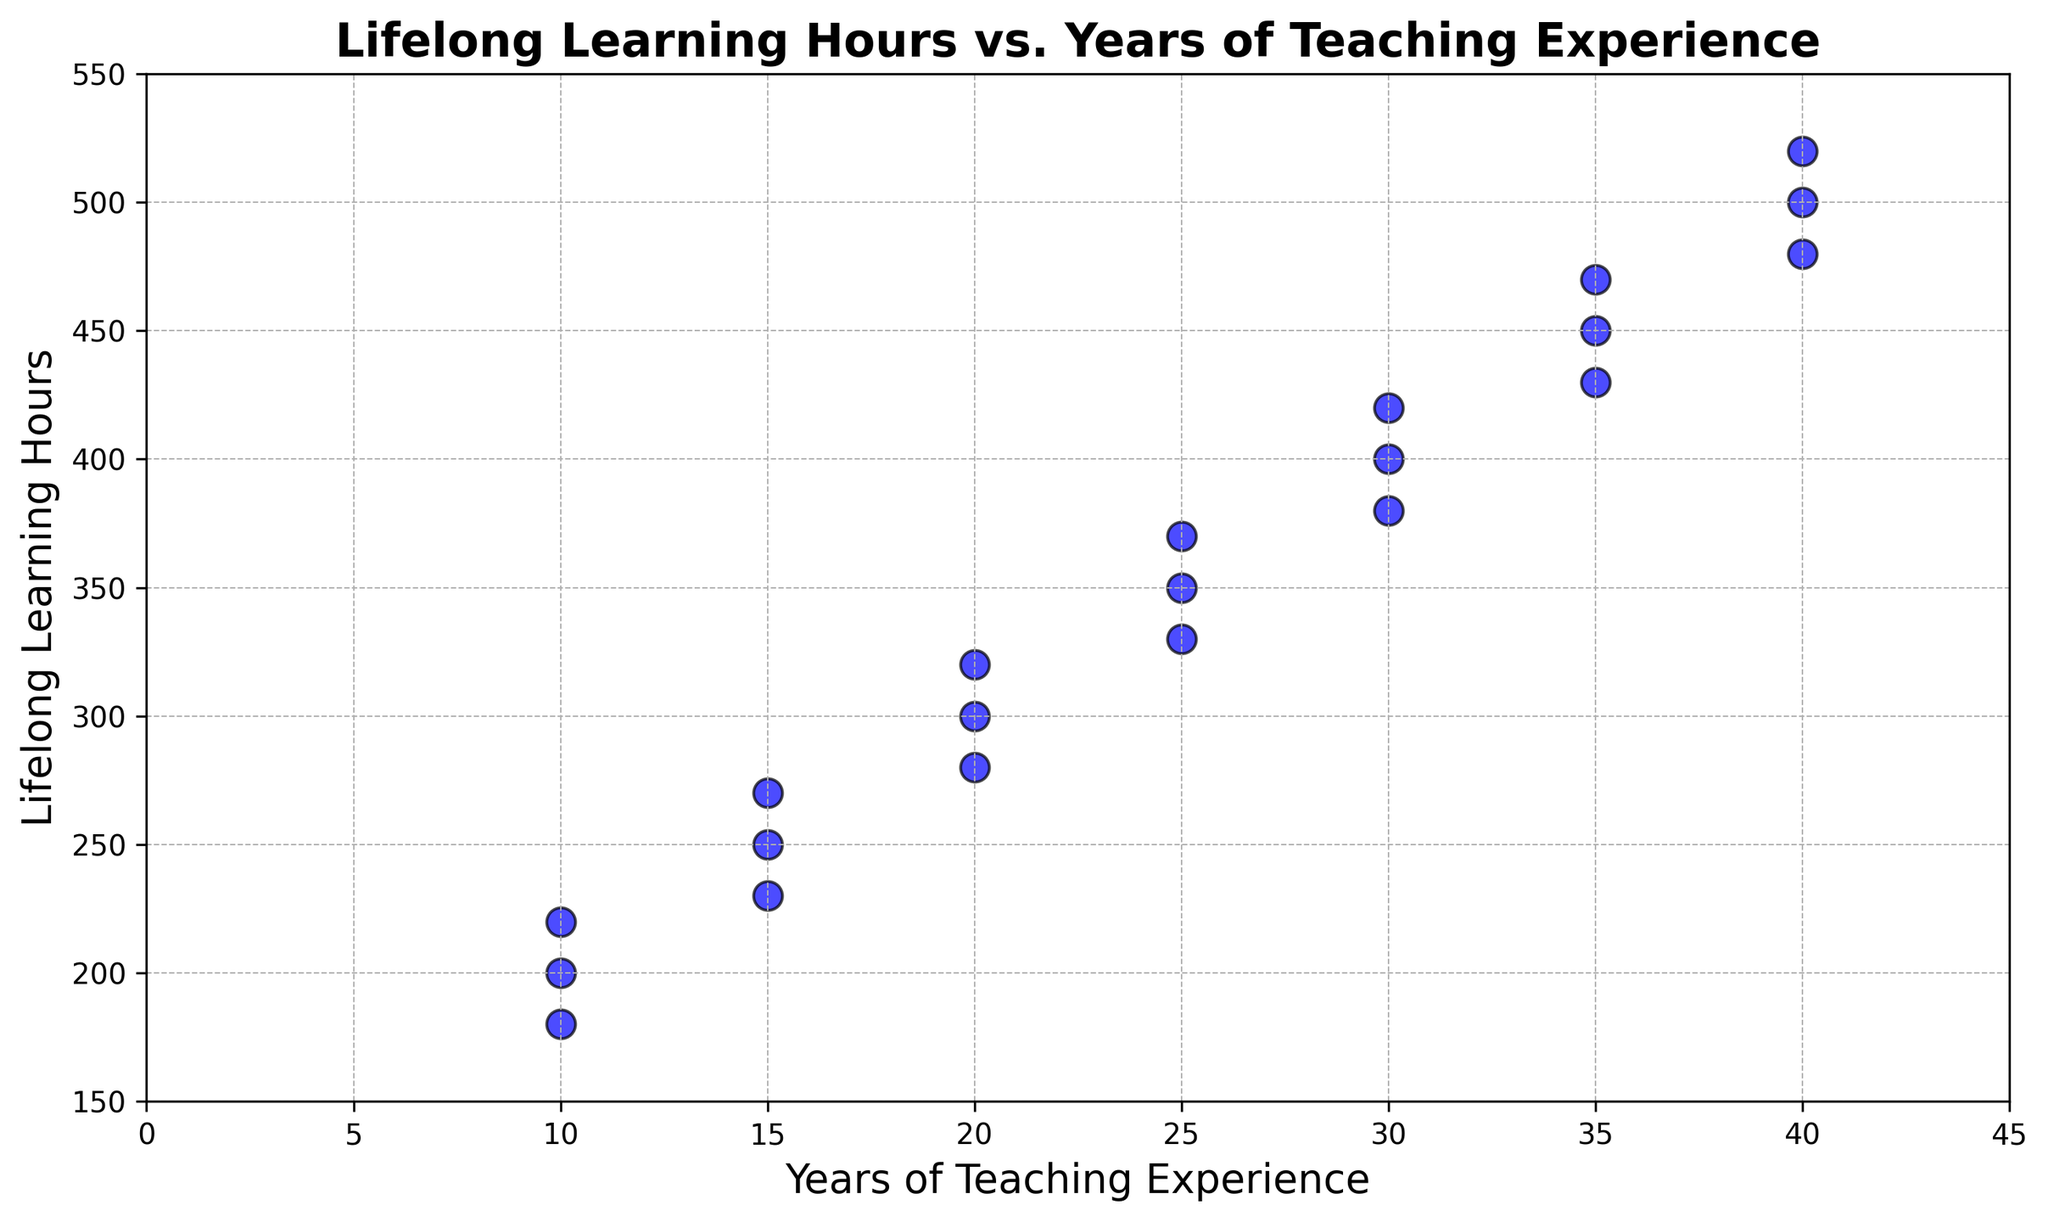What is the range of Lifelong Learning Hours among teachers with 20 years of experience? To find the range, identify the minimum and maximum Lifelong Learning Hours for teachers with 20 years of experience. The observed values are 300, 280, and 320. The range is the difference between the highest and lowest values: 320 - 280 = 40.
Answer: 40 Which group of teachers has the most outliers in Lifelong Learning Hours data? Scan the plot and identify points that significantly deviate from the general trend. Teachers with 30 years of experience have points at 380 and 420, indicating higher variability and potential outliers.
Answer: Teachers with 30 years of experience What is the typical (or modal) trend in Lifelong Learning Hours as teaching experience increases? The scatter plot shows an upward trend in Lifelong Learning Hours as teaching experience increases. This can be observed as most data points form a pattern that rises consistently.
Answer: Upward trend Compare the Lifelong Learning Hours for teachers with 15 and 35 years of teaching experience. Which group has higher hours on average? Identify the Lifelong Learning Hours for teachers with 15 years (250, 230, 270) and those with 35 years (450, 430, 470). Calculate the average for each group: (250+230+270)/3 = 250, and (450+430+470)/3 = 450. Thus, teachers with 35 years have higher hours on average.
Answer: Teachers with 35 years Are there any teachers who have exactly 10 years of teaching experience and over 200 Lifelong Learning Hours? Look at the data points for 10 years of teaching experience and check if any points are above 200 Lifelong Learning Hours. Points at 200, 180, and 220 exist, with one point above 200.
Answer: Yes Is there a linear relationship between years of teaching experience and Lifelong Learning Hours? Observe the scatter plot. The data points form an approximate linear upward trend, suggesting a linear relationship between the two variables.
Answer: Yes What is the difference in Lifelong Learning Hours between the two teachers with the highest teaching experience? Identify the Lifelong Learning Hours for the two teachers at 40 years of experience (500, 480, and 520). The two highest values are 520 and 500. The difference is 520 - 500 = 20.
Answer: 20 How does variability of Lifelong Learning Hours change with teaching experience? Examine the spread of data points for different years of teaching experience. For years of experience like 10 and 15, variability is higher, shown by more dispersed points. For higher experience like 40, points are closely clustered, indicating less variability.
Answer: Decreases with experience What is the least common value range for Lifelong Learning Hours between all groups? Review the plot and identify Lifelong Learning Hours ranges with fewer points. The range 150-200 has the least points compared to others.
Answer: 150-200 Which teacher has the highest Lifelong Learning Hours and how many years of teaching experience does this teacher have? Find the point with the highest Lifelong Learning Hours value on the plot. The highest value is 520 Hours, corresponding to 40 years of teaching experience.
Answer: 40 years, 520 Hours 